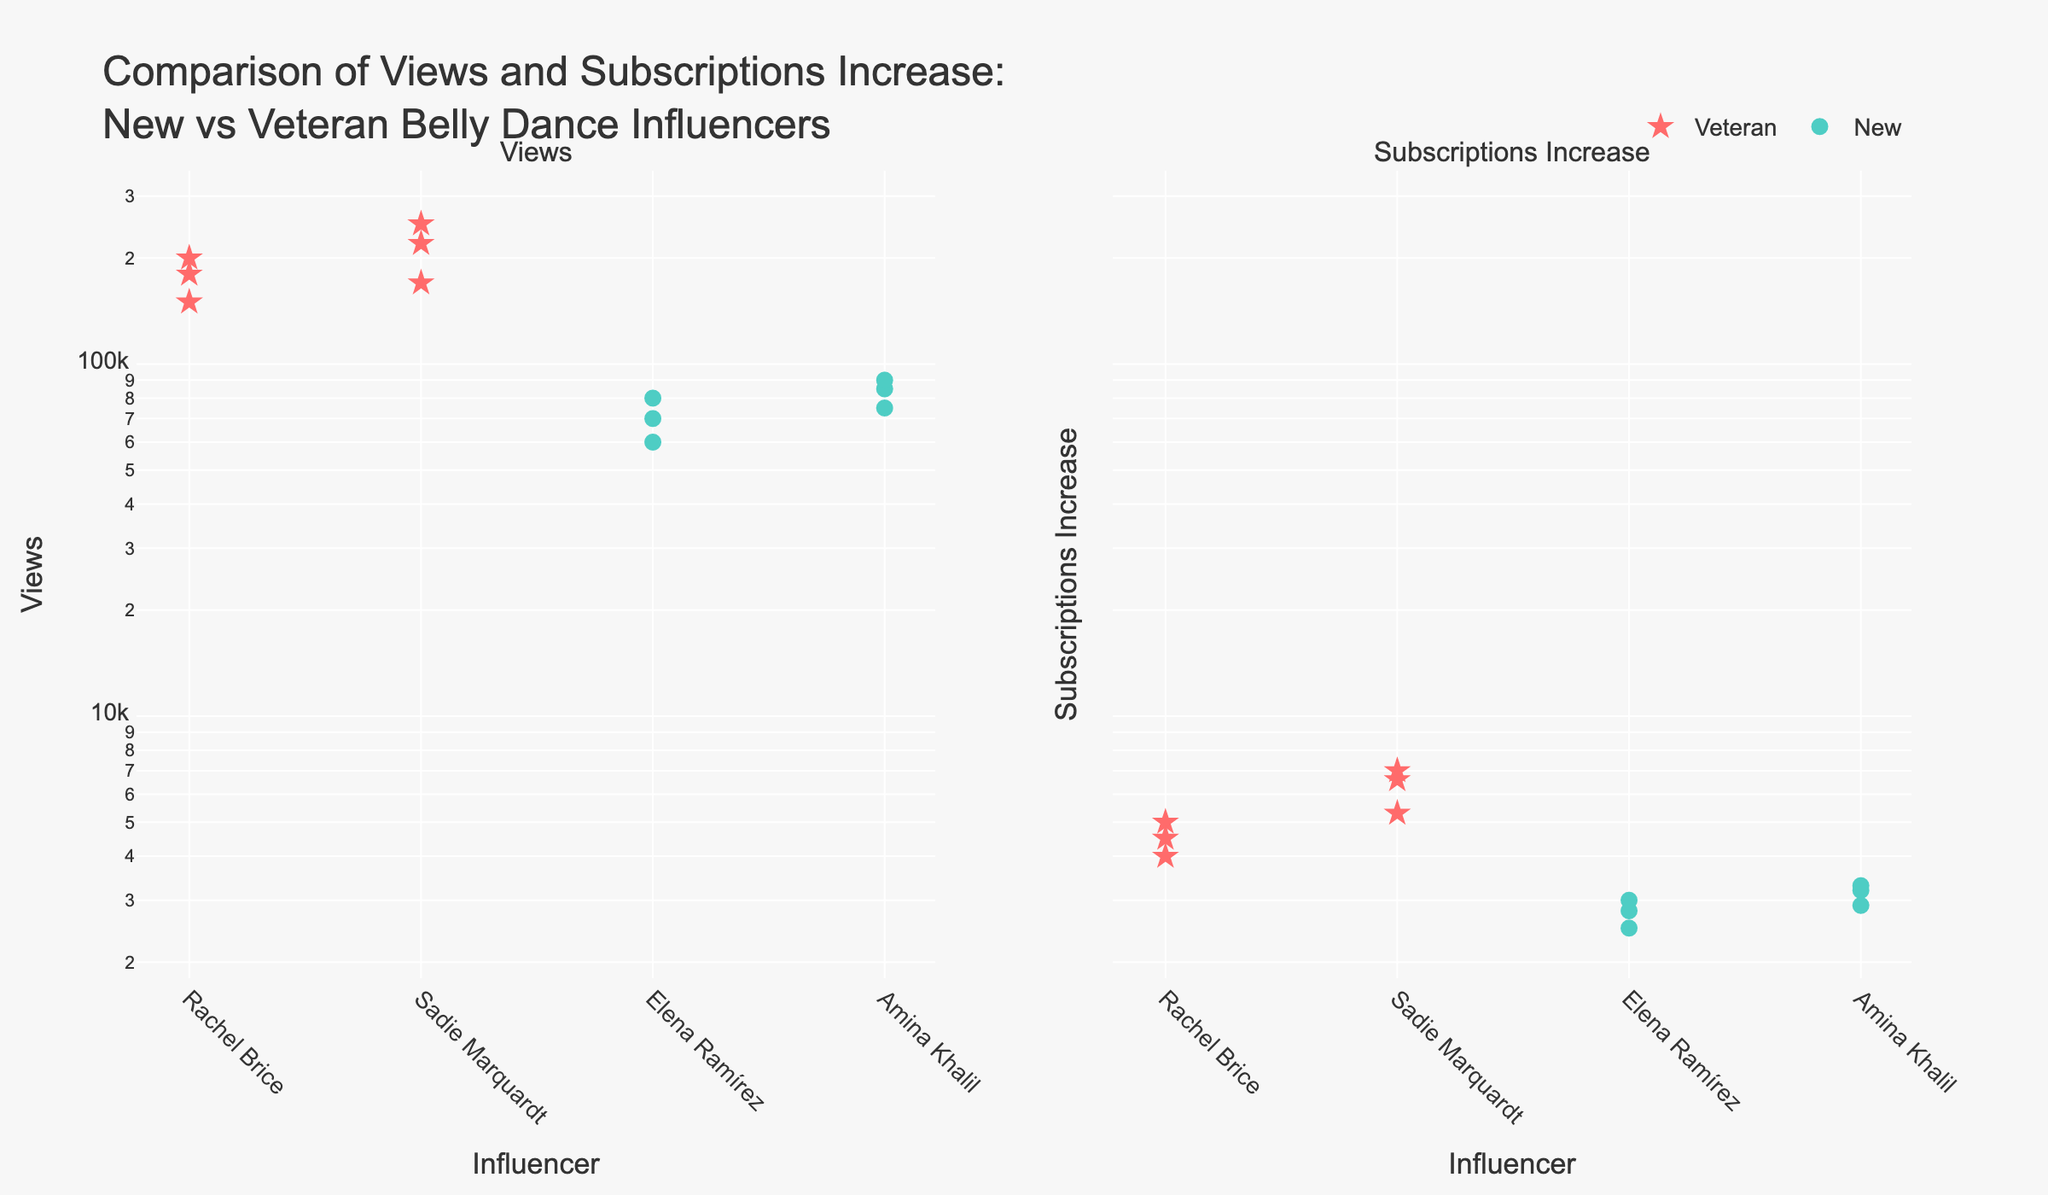What is the title of the subplot on the left? The title of the subplot on the left is shown at the top above the subplot in the figure.
Answer: Views Which influencer among the veterans has the highest number of views? Among the veterans, compare the data points: Rachel Brice and Sadie Marquardt; find the marker with the highest y-value in the Views subplot.
Answer: Sadie Marquardt How many new influencers are shown in the figure? Count the unique names among the veteran influencers in the x-axis labels or the markers in the subplots.
Answer: 2 Which video by new influencers has the highest subscription increase? Refer to the subplot on the right, locate the markers for new influencers, and identify the one with the highest y-value.
Answer: Basic Moves and Steps Is there any veteran whose subscription increase is lower than any new influencer's? Compare the lowest subscription increases of veterans with the highest subscription increases of new influencers by looking at the markers in the subplot on the right.
Answer: No What are the ranges of views and subscription increases for veteran influencers? In the Views and Subscriptions Increase subplots, identify the lowest and highest y-values among the markers for veteran influencers.
Answer: Views: 150,000 - 250,000, Subscriptions Increase: 4,000 - 7,000 Which type of influencer generally has higher subscriptions increase, veterans or new influencers? Compare the general height of the markers between two groups in the Subscriptions Increase subplot.
Answer: Veterans Are there any influencers with the same number of views but different subscription increases? Look for markers that align horizontally in the Views subplot and check their corresponding positions in the Subscriptions Increase subplot.
Answer: No What is the ratio of the highest views to the lowest views for new influencers? Find the highest and lowest y-values in the Views subplot for new influencers, then compute the ratio. (Highest View: 90,000, Lowest View: 60,000, Ratio: 90,000/60,000)
Answer: 1.5 